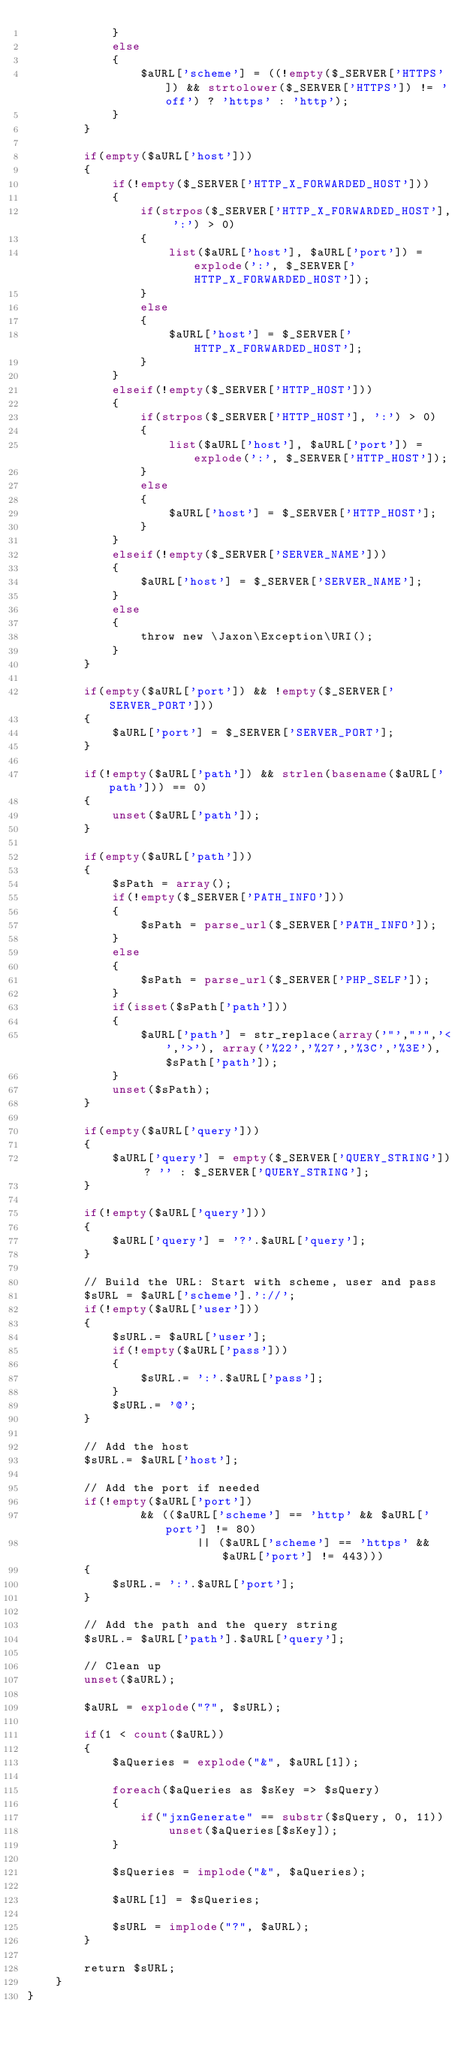<code> <loc_0><loc_0><loc_500><loc_500><_PHP_>            }
            else
            {
                $aURL['scheme'] = ((!empty($_SERVER['HTTPS']) && strtolower($_SERVER['HTTPS']) != 'off') ? 'https' : 'http');
            }
        }
        
        if(empty($aURL['host']))
        {
            if(!empty($_SERVER['HTTP_X_FORWARDED_HOST']))
            {
                if(strpos($_SERVER['HTTP_X_FORWARDED_HOST'], ':') > 0)
                {
                    list($aURL['host'], $aURL['port']) = explode(':', $_SERVER['HTTP_X_FORWARDED_HOST']);
                }
                else
                {
                    $aURL['host'] = $_SERVER['HTTP_X_FORWARDED_HOST'];
                }
            }
            elseif(!empty($_SERVER['HTTP_HOST']))
            {
                if(strpos($_SERVER['HTTP_HOST'], ':') > 0)
                {
                    list($aURL['host'], $aURL['port']) = explode(':', $_SERVER['HTTP_HOST']);
                }
                else
                {
                    $aURL['host'] = $_SERVER['HTTP_HOST'];
                }
            }
            elseif(!empty($_SERVER['SERVER_NAME']))
            {
                $aURL['host'] = $_SERVER['SERVER_NAME'];
            }
            else
            {
                throw new \Jaxon\Exception\URI();
            }
        }
        
        if(empty($aURL['port']) && !empty($_SERVER['SERVER_PORT']))
        {
            $aURL['port'] = $_SERVER['SERVER_PORT'];
        }
        
        if(!empty($aURL['path']) && strlen(basename($aURL['path'])) == 0)
        {
            unset($aURL['path']);
        }
        
        if(empty($aURL['path']))
        {
            $sPath = array();
            if(!empty($_SERVER['PATH_INFO']))
            {
                $sPath = parse_url($_SERVER['PATH_INFO']);
            }
            else
            {
                $sPath = parse_url($_SERVER['PHP_SELF']);
            }
            if(isset($sPath['path']))
            {
                $aURL['path'] = str_replace(array('"',"'",'<','>'), array('%22','%27','%3C','%3E'), $sPath['path']);
            }
            unset($sPath);
        }
        
        if(empty($aURL['query']))
        {
            $aURL['query'] = empty($_SERVER['QUERY_STRING']) ? '' : $_SERVER['QUERY_STRING'];
        }
        
        if(!empty($aURL['query']))
        {
            $aURL['query'] = '?'.$aURL['query'];
        }
        
        // Build the URL: Start with scheme, user and pass
        $sURL = $aURL['scheme'].'://';
        if(!empty($aURL['user']))
        {
            $sURL.= $aURL['user'];
            if(!empty($aURL['pass']))
            {
                $sURL.= ':'.$aURL['pass'];
            }
            $sURL.= '@';
        }
        
        // Add the host
        $sURL.= $aURL['host'];
        
        // Add the port if needed
        if(!empty($aURL['port'])
                && (($aURL['scheme'] == 'http' && $aURL['port'] != 80)
                        || ($aURL['scheme'] == 'https' && $aURL['port'] != 443)))
        {
            $sURL.= ':'.$aURL['port'];
        }
        
        // Add the path and the query string
        $sURL.= $aURL['path'].$aURL['query'];
        
        // Clean up
        unset($aURL);
        
        $aURL = explode("?", $sURL);
        
        if(1 < count($aURL))
        {
            $aQueries = explode("&", $aURL[1]);
        
            foreach($aQueries as $sKey => $sQuery)
            {
                if("jxnGenerate" == substr($sQuery, 0, 11))
                    unset($aQueries[$sKey]);
            }
                
            $sQueries = implode("&", $aQueries);
                
            $aURL[1] = $sQueries;
                
            $sURL = implode("?", $aURL);
        }
        
        return $sURL;
    }
}
</code> 